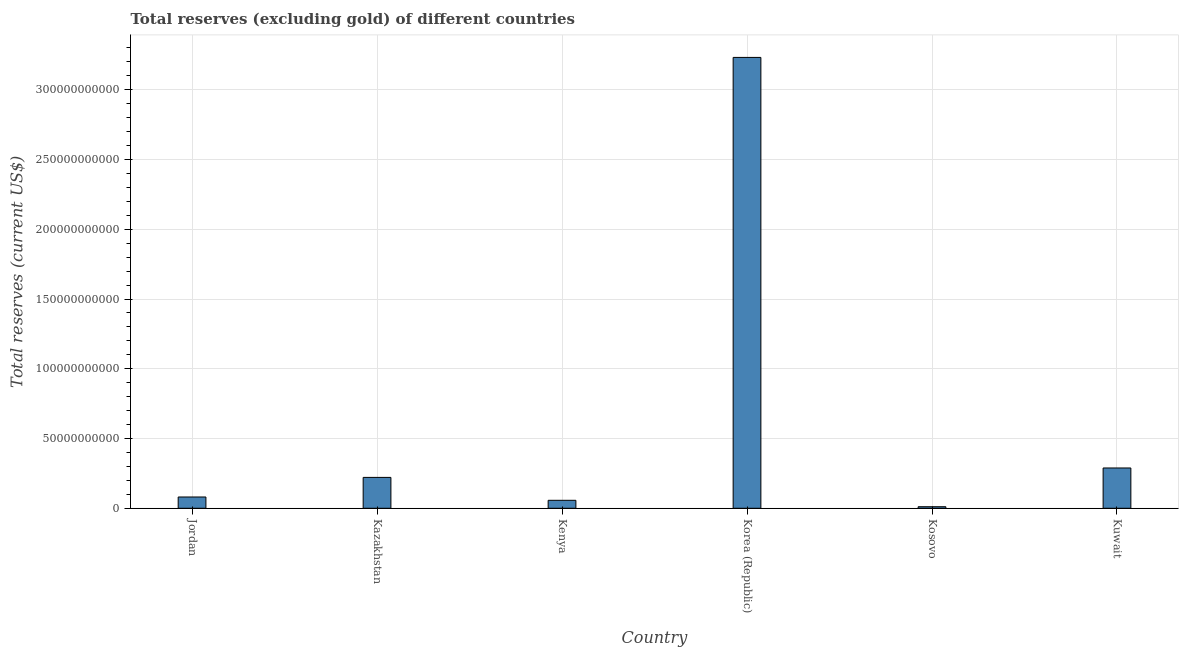What is the title of the graph?
Keep it short and to the point. Total reserves (excluding gold) of different countries. What is the label or title of the Y-axis?
Make the answer very short. Total reserves (current US$). What is the total reserves (excluding gold) in Kuwait?
Make the answer very short. 2.89e+1. Across all countries, what is the maximum total reserves (excluding gold)?
Your answer should be compact. 3.23e+11. Across all countries, what is the minimum total reserves (excluding gold)?
Your response must be concise. 1.11e+09. In which country was the total reserves (excluding gold) maximum?
Offer a terse response. Korea (Republic). In which country was the total reserves (excluding gold) minimum?
Your answer should be compact. Kosovo. What is the sum of the total reserves (excluding gold)?
Make the answer very short. 3.89e+11. What is the difference between the total reserves (excluding gold) in Jordan and Kenya?
Your answer should be compact. 2.38e+09. What is the average total reserves (excluding gold) per country?
Provide a succinct answer. 6.49e+1. What is the median total reserves (excluding gold)?
Your response must be concise. 1.51e+1. What is the ratio of the total reserves (excluding gold) in Jordan to that in Kuwait?
Your response must be concise. 0.28. What is the difference between the highest and the second highest total reserves (excluding gold)?
Keep it short and to the point. 2.94e+11. What is the difference between the highest and the lowest total reserves (excluding gold)?
Keep it short and to the point. 3.22e+11. In how many countries, is the total reserves (excluding gold) greater than the average total reserves (excluding gold) taken over all countries?
Keep it short and to the point. 1. How many bars are there?
Offer a very short reply. 6. How many countries are there in the graph?
Your answer should be very brief. 6. Are the values on the major ticks of Y-axis written in scientific E-notation?
Your answer should be compact. No. What is the Total reserves (current US$) of Jordan?
Give a very brief answer. 8.09e+09. What is the Total reserves (current US$) of Kazakhstan?
Your response must be concise. 2.21e+1. What is the Total reserves (current US$) of Kenya?
Offer a terse response. 5.71e+09. What is the Total reserves (current US$) in Korea (Republic)?
Your answer should be compact. 3.23e+11. What is the Total reserves (current US$) of Kosovo?
Your response must be concise. 1.11e+09. What is the Total reserves (current US$) of Kuwait?
Ensure brevity in your answer.  2.89e+1. What is the difference between the Total reserves (current US$) in Jordan and Kazakhstan?
Offer a very short reply. -1.40e+1. What is the difference between the Total reserves (current US$) in Jordan and Kenya?
Provide a short and direct response. 2.38e+09. What is the difference between the Total reserves (current US$) in Jordan and Korea (Republic)?
Your answer should be compact. -3.15e+11. What is the difference between the Total reserves (current US$) in Jordan and Kosovo?
Provide a short and direct response. 6.98e+09. What is the difference between the Total reserves (current US$) in Jordan and Kuwait?
Your answer should be very brief. -2.08e+1. What is the difference between the Total reserves (current US$) in Kazakhstan and Kenya?
Provide a succinct answer. 1.64e+1. What is the difference between the Total reserves (current US$) in Kazakhstan and Korea (Republic)?
Your answer should be very brief. -3.01e+11. What is the difference between the Total reserves (current US$) in Kazakhstan and Kosovo?
Provide a short and direct response. 2.10e+1. What is the difference between the Total reserves (current US$) in Kazakhstan and Kuwait?
Keep it short and to the point. -6.75e+09. What is the difference between the Total reserves (current US$) in Kenya and Korea (Republic)?
Your answer should be compact. -3.17e+11. What is the difference between the Total reserves (current US$) in Kenya and Kosovo?
Offer a very short reply. 4.60e+09. What is the difference between the Total reserves (current US$) in Kenya and Kuwait?
Keep it short and to the point. -2.32e+1. What is the difference between the Total reserves (current US$) in Korea (Republic) and Kosovo?
Give a very brief answer. 3.22e+11. What is the difference between the Total reserves (current US$) in Korea (Republic) and Kuwait?
Make the answer very short. 2.94e+11. What is the difference between the Total reserves (current US$) in Kosovo and Kuwait?
Provide a succinct answer. -2.78e+1. What is the ratio of the Total reserves (current US$) in Jordan to that in Kazakhstan?
Provide a succinct answer. 0.37. What is the ratio of the Total reserves (current US$) in Jordan to that in Kenya?
Your answer should be very brief. 1.42. What is the ratio of the Total reserves (current US$) in Jordan to that in Korea (Republic)?
Ensure brevity in your answer.  0.03. What is the ratio of the Total reserves (current US$) in Jordan to that in Kuwait?
Give a very brief answer. 0.28. What is the ratio of the Total reserves (current US$) in Kazakhstan to that in Kenya?
Give a very brief answer. 3.88. What is the ratio of the Total reserves (current US$) in Kazakhstan to that in Korea (Republic)?
Your answer should be very brief. 0.07. What is the ratio of the Total reserves (current US$) in Kazakhstan to that in Kosovo?
Your answer should be very brief. 19.97. What is the ratio of the Total reserves (current US$) in Kazakhstan to that in Kuwait?
Your answer should be compact. 0.77. What is the ratio of the Total reserves (current US$) in Kenya to that in Korea (Republic)?
Ensure brevity in your answer.  0.02. What is the ratio of the Total reserves (current US$) in Kenya to that in Kosovo?
Provide a succinct answer. 5.15. What is the ratio of the Total reserves (current US$) in Kenya to that in Kuwait?
Give a very brief answer. 0.2. What is the ratio of the Total reserves (current US$) in Korea (Republic) to that in Kosovo?
Ensure brevity in your answer.  291.68. What is the ratio of the Total reserves (current US$) in Korea (Republic) to that in Kuwait?
Keep it short and to the point. 11.19. What is the ratio of the Total reserves (current US$) in Kosovo to that in Kuwait?
Ensure brevity in your answer.  0.04. 